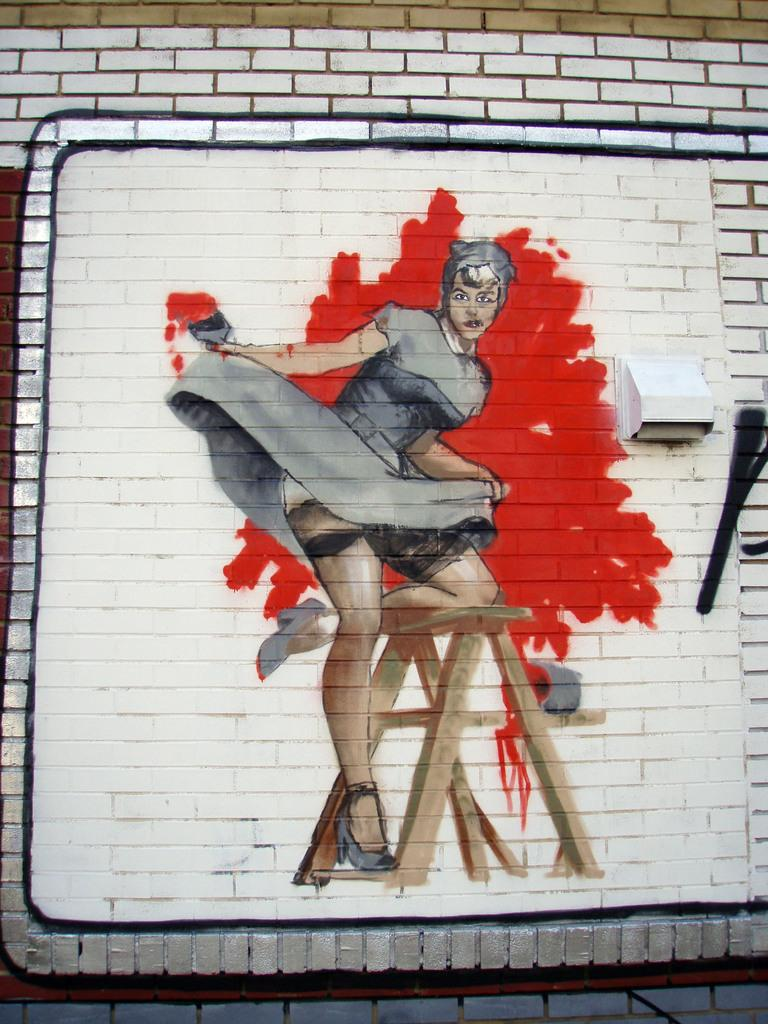What is present on the wall in the image? There is a painting on the wall. What is the subject of the painting? The painting depicts a female. What is the female doing in the painting? The female is standing on a table in the painting. What type of pickle is being used in the operation depicted in the painting? There is no operation or pickle present in the painting; it depicts a female standing on a table. 